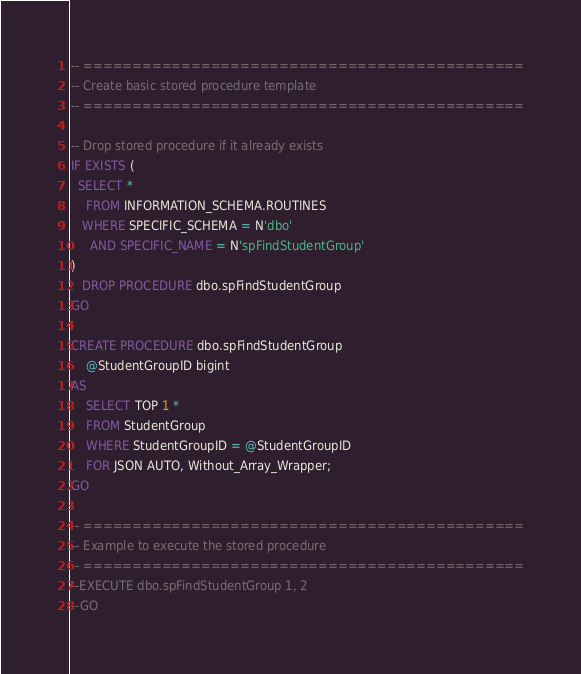<code> <loc_0><loc_0><loc_500><loc_500><_SQL_>-- =============================================
-- Create basic stored procedure template
-- =============================================

-- Drop stored procedure if it already exists
IF EXISTS (
  SELECT * 
    FROM INFORMATION_SCHEMA.ROUTINES 
   WHERE SPECIFIC_SCHEMA = N'dbo'
     AND SPECIFIC_NAME = N'spFindStudentGroup' 
)
   DROP PROCEDURE dbo.spFindStudentGroup
GO

CREATE PROCEDURE dbo.spFindStudentGroup
	@StudentGroupID bigint
AS
	SELECT TOP 1 *
	FROM StudentGroup
	WHERE StudentGroupID = @StudentGroupID
	FOR JSON AUTO, Without_Array_Wrapper;
GO

-- =============================================
-- Example to execute the stored procedure
-- =============================================
--EXECUTE dbo.spFindStudentGroup 1, 2
--GO
</code> 